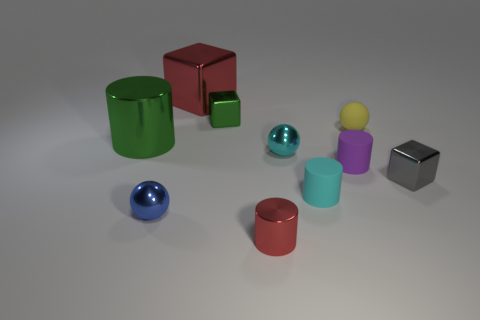How big is the cyan ball?
Ensure brevity in your answer.  Small. Are the big cube that is left of the gray metal object and the small cyan cylinder made of the same material?
Ensure brevity in your answer.  No. What number of yellow matte spheres are there?
Your answer should be very brief. 1. What number of objects are either red shiny objects or small purple balls?
Offer a very short reply. 2. There is a green shiny object to the left of the tiny metallic sphere to the left of the cyan metal thing; what number of big green things are in front of it?
Give a very brief answer. 0. Is there any other thing of the same color as the large metal cube?
Give a very brief answer. Yes. Is the color of the small rubber thing that is in front of the gray metallic object the same as the tiny metallic ball that is behind the blue shiny object?
Your answer should be very brief. Yes. Are there more red objects in front of the blue metal ball than large metallic blocks that are on the right side of the cyan rubber object?
Keep it short and to the point. Yes. What material is the small purple thing?
Your response must be concise. Rubber. What is the shape of the red shiny object that is behind the shiny cylinder left of the green metal object that is to the right of the green cylinder?
Your answer should be very brief. Cube. 